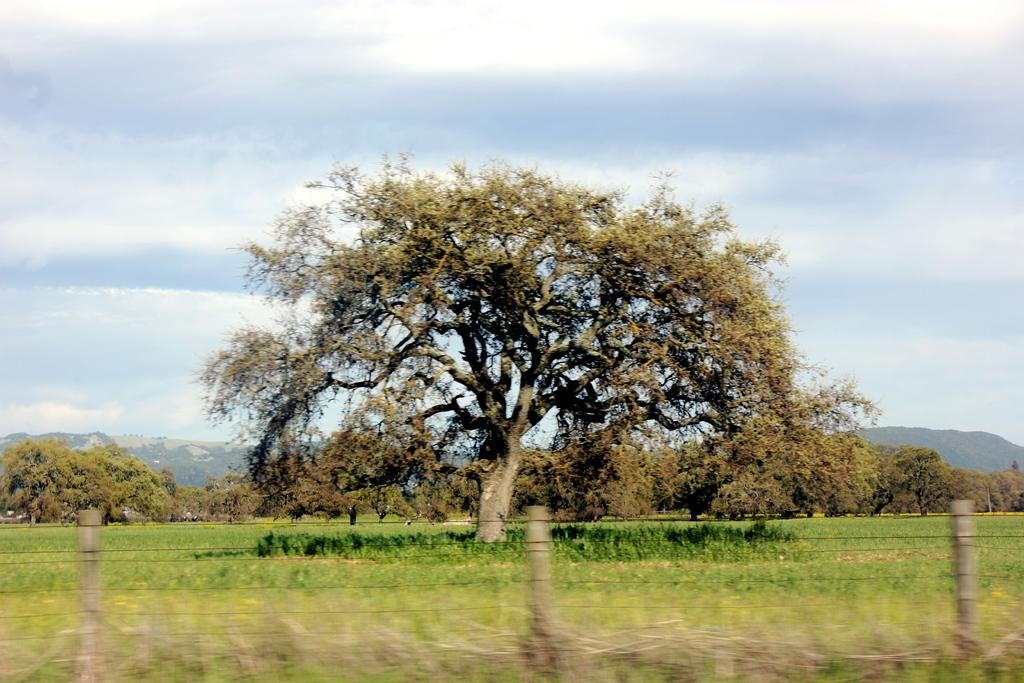What type of barrier can be seen in the image? There is a fence in the image. What type of vegetation is present in the image? There are trees in the image. What type of natural landform can be seen in the image? There are mountains in the image. What type of ground cover is present in the image? There is grass in the image. What is visible in the background of the image? The sky is visible in the background of the image. What can be seen in the sky in the image? Clouds are present in the sky. What type of paper is being used to create the mountains in the image? There is no paper present in the image; the mountains are a natural landform. How many fifths are visible in the image? There is no reference to a "fifth" in the image, so it cannot be counted or quantified. 